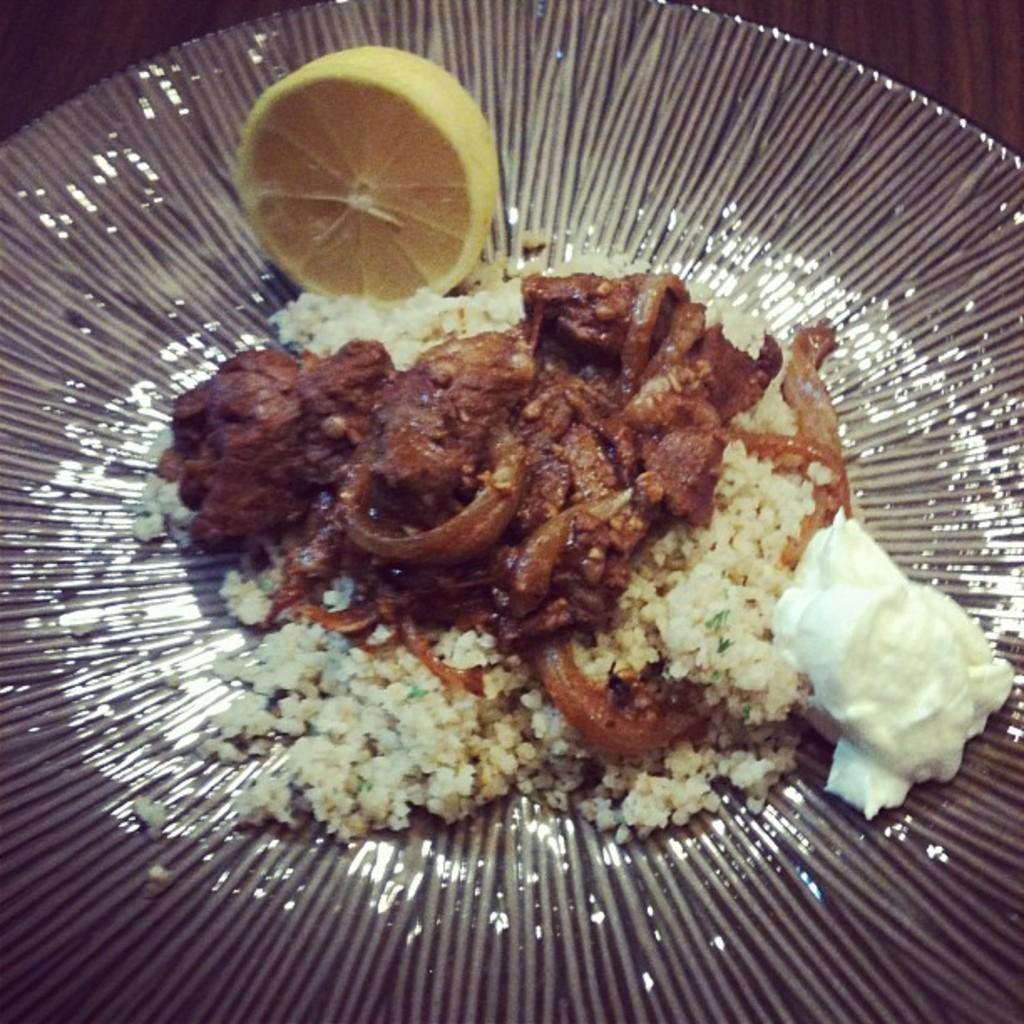What is present on the plate in the image? The plate contains different types of food. Can you identify any specific food items on the plate? Yes, there is a lemon on the plate. Is the plate sinking into the quicksand in the image? There is no quicksand present in the image, so the plate is not sinking into it. 